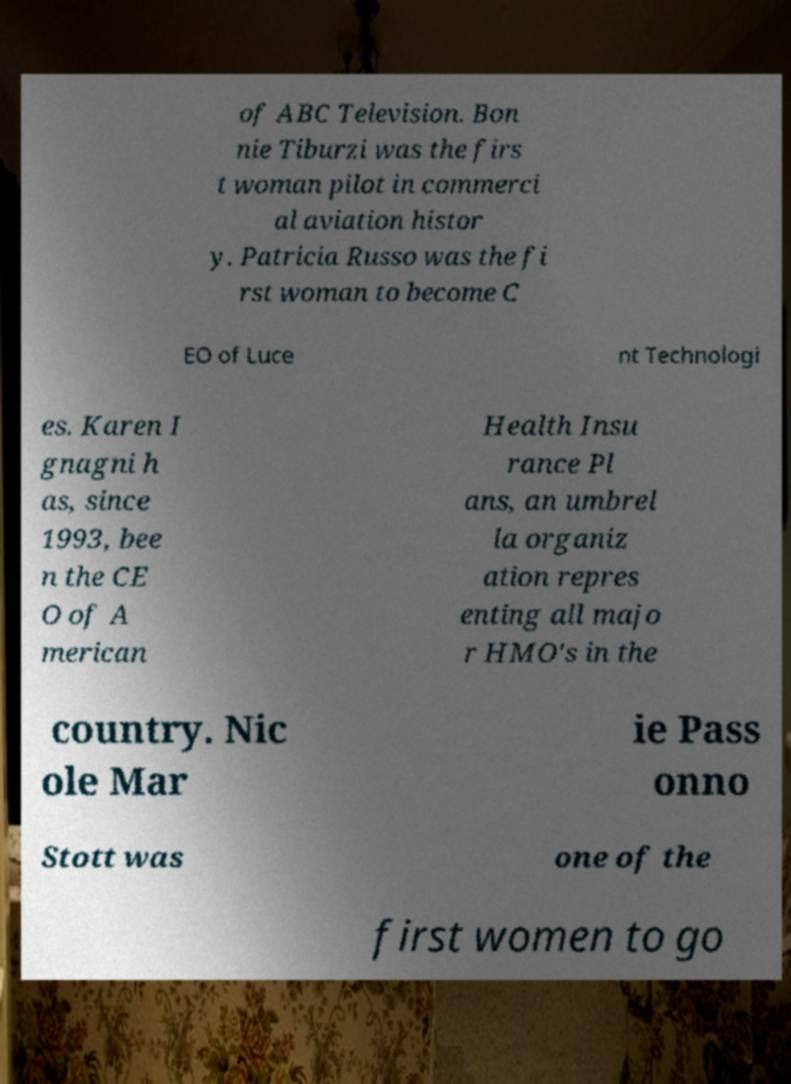Could you extract and type out the text from this image? of ABC Television. Bon nie Tiburzi was the firs t woman pilot in commerci al aviation histor y. Patricia Russo was the fi rst woman to become C EO of Luce nt Technologi es. Karen I gnagni h as, since 1993, bee n the CE O of A merican Health Insu rance Pl ans, an umbrel la organiz ation repres enting all majo r HMO's in the country. Nic ole Mar ie Pass onno Stott was one of the first women to go 